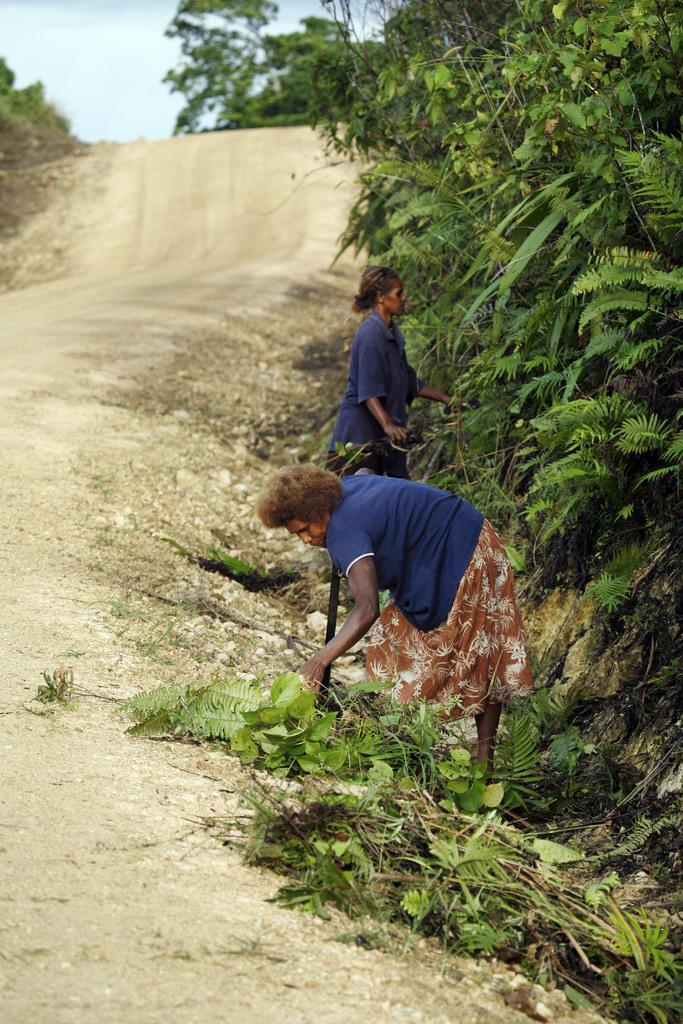Who are the main subjects in the image? There are two ladies in the center of the image. What can be seen on the right side of the image? There are trees on the right side of the image. What is located on the left side of the image? There is a path on the left side of the image. What type of stitch is being used by the ladies in the image? There is no indication of any stitching or sewing activity in the image; the ladies are not holding any sewing materials. 